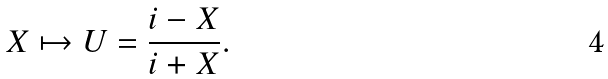<formula> <loc_0><loc_0><loc_500><loc_500>X \mapsto U = \frac { i - X } { i + X } .</formula> 